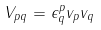<formula> <loc_0><loc_0><loc_500><loc_500>V _ { p q } = \epsilon ^ { p } _ { q } v _ { p } v _ { q }</formula> 